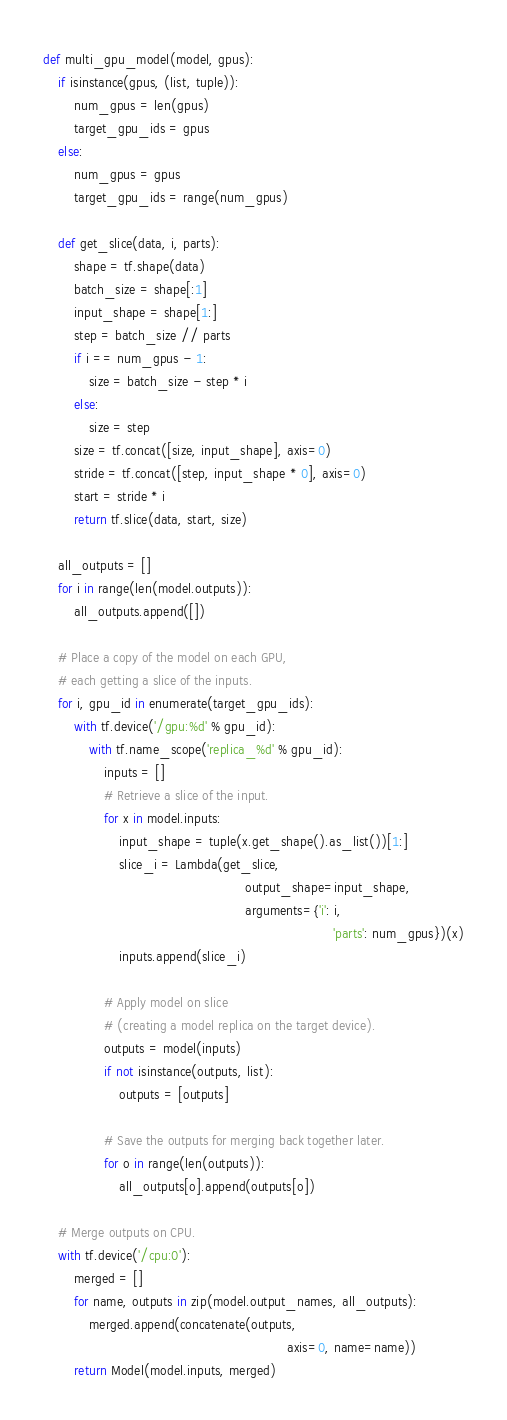Convert code to text. <code><loc_0><loc_0><loc_500><loc_500><_Python_>def multi_gpu_model(model, gpus):
    if isinstance(gpus, (list, tuple)):
        num_gpus = len(gpus)
        target_gpu_ids = gpus
    else:
        num_gpus = gpus
        target_gpu_ids = range(num_gpus)

    def get_slice(data, i, parts):
        shape = tf.shape(data)
        batch_size = shape[:1]
        input_shape = shape[1:]
        step = batch_size // parts
        if i == num_gpus - 1:
            size = batch_size - step * i
        else:
            size = step
        size = tf.concat([size, input_shape], axis=0)
        stride = tf.concat([step, input_shape * 0], axis=0)
        start = stride * i
        return tf.slice(data, start, size)

    all_outputs = []
    for i in range(len(model.outputs)):
        all_outputs.append([])

    # Place a copy of the model on each GPU,
    # each getting a slice of the inputs.
    for i, gpu_id in enumerate(target_gpu_ids):
        with tf.device('/gpu:%d' % gpu_id):
            with tf.name_scope('replica_%d' % gpu_id):
                inputs = []
                # Retrieve a slice of the input.
                for x in model.inputs:
                    input_shape = tuple(x.get_shape().as_list())[1:]
                    slice_i = Lambda(get_slice,
                                                     output_shape=input_shape,
                                                     arguments={'i': i,
                                                                            'parts': num_gpus})(x)
                    inputs.append(slice_i)

                # Apply model on slice
                # (creating a model replica on the target device).
                outputs = model(inputs)
                if not isinstance(outputs, list):
                    outputs = [outputs]

                # Save the outputs for merging back together later.
                for o in range(len(outputs)):
                    all_outputs[o].append(outputs[o])

    # Merge outputs on CPU.
    with tf.device('/cpu:0'):
        merged = []
        for name, outputs in zip(model.output_names, all_outputs):
            merged.append(concatenate(outputs,
                                                                axis=0, name=name))
        return Model(model.inputs, merged)
</code> 